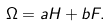<formula> <loc_0><loc_0><loc_500><loc_500>\Omega = a H + b F .</formula> 